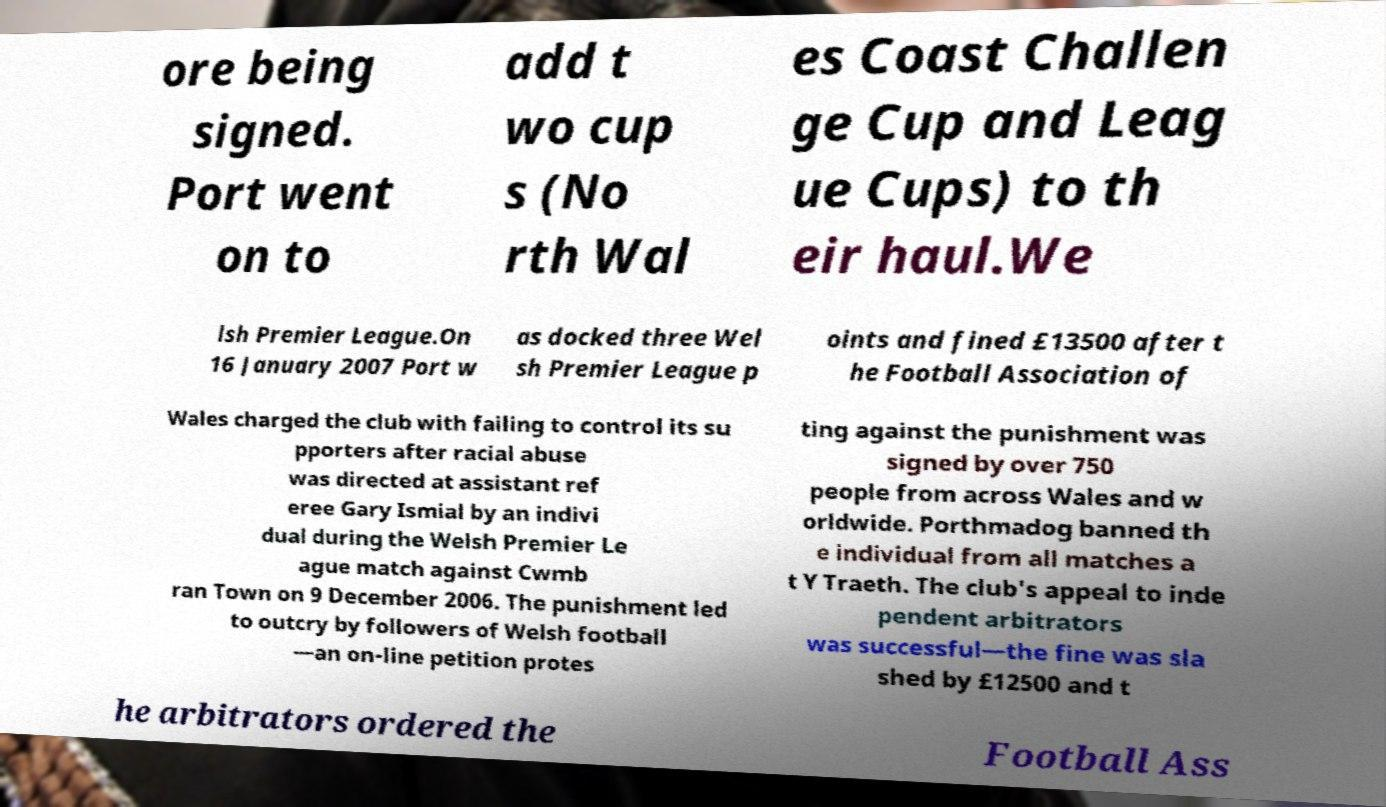Could you assist in decoding the text presented in this image and type it out clearly? ore being signed. Port went on to add t wo cup s (No rth Wal es Coast Challen ge Cup and Leag ue Cups) to th eir haul.We lsh Premier League.On 16 January 2007 Port w as docked three Wel sh Premier League p oints and fined £13500 after t he Football Association of Wales charged the club with failing to control its su pporters after racial abuse was directed at assistant ref eree Gary Ismial by an indivi dual during the Welsh Premier Le ague match against Cwmb ran Town on 9 December 2006. The punishment led to outcry by followers of Welsh football —an on-line petition protes ting against the punishment was signed by over 750 people from across Wales and w orldwide. Porthmadog banned th e individual from all matches a t Y Traeth. The club's appeal to inde pendent arbitrators was successful—the fine was sla shed by £12500 and t he arbitrators ordered the Football Ass 